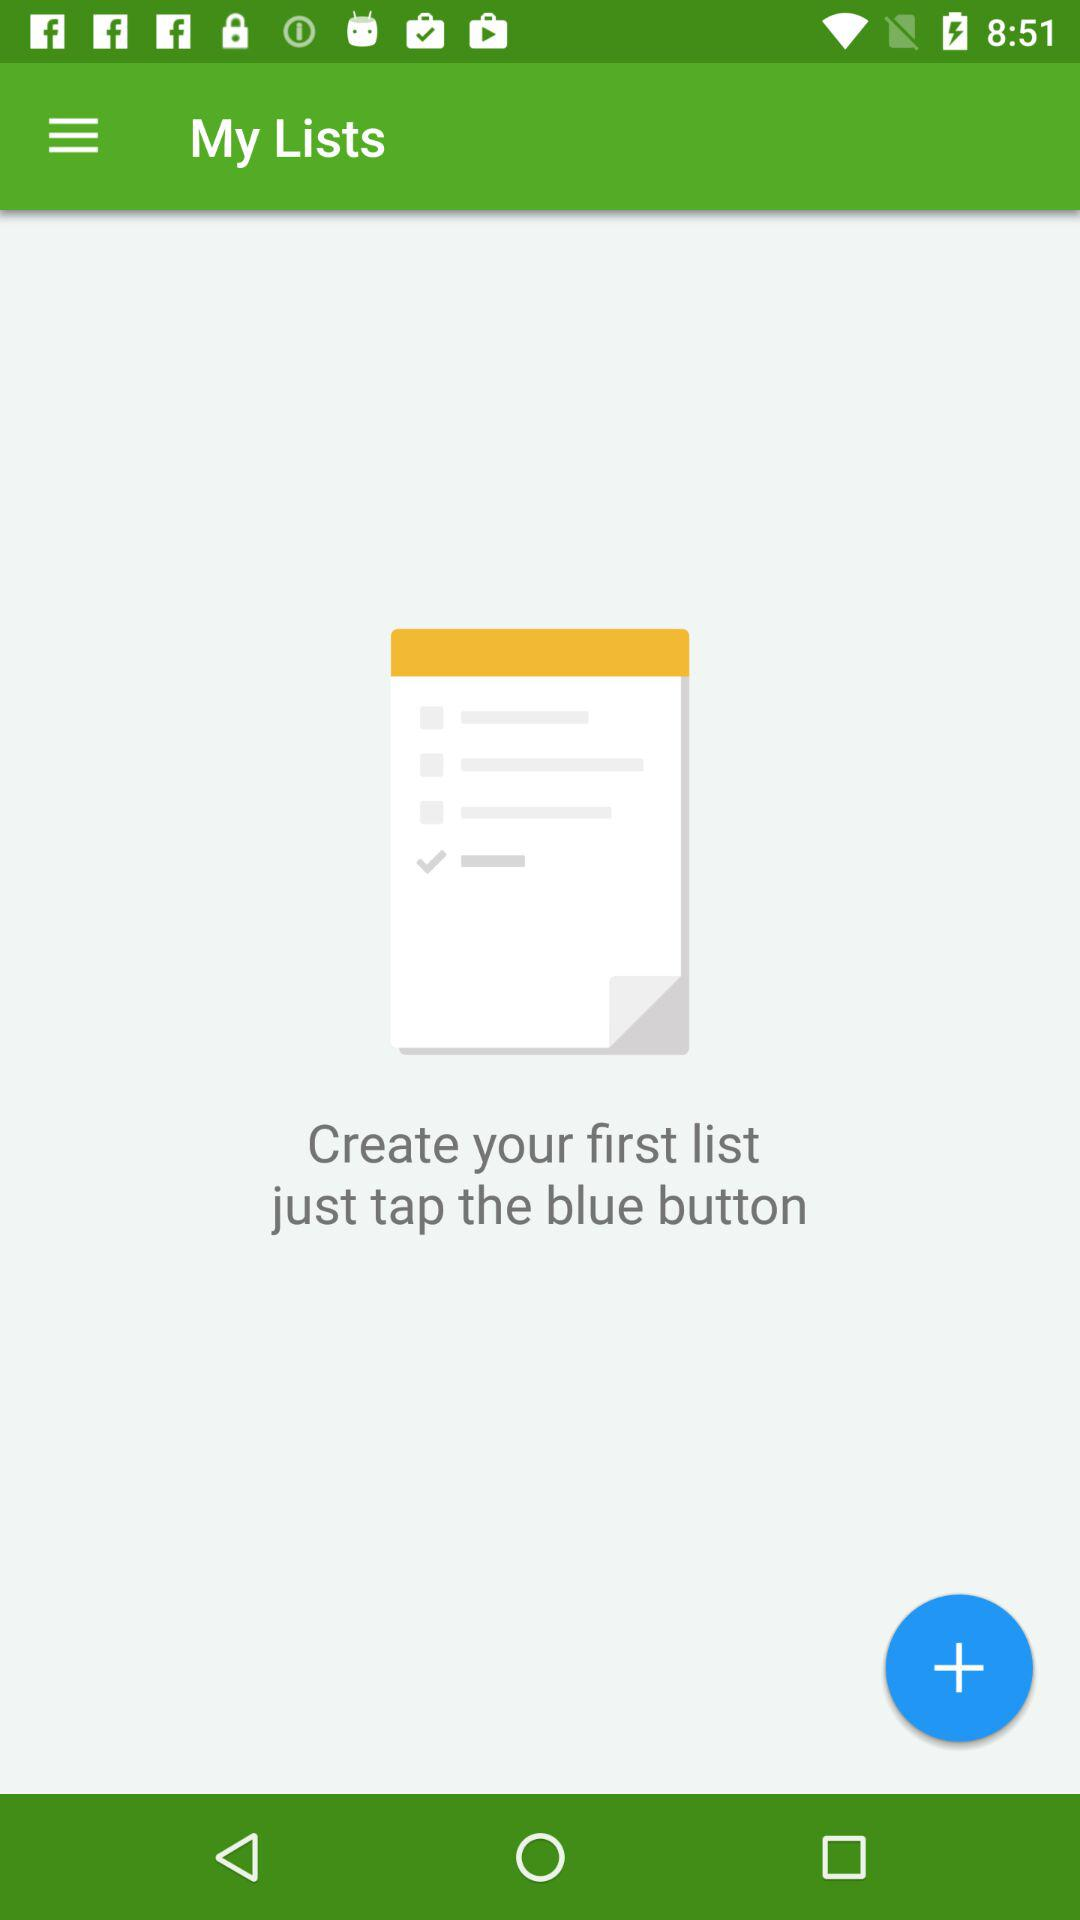What button should we tap to create a list? You should tap the blue button to create a list. 